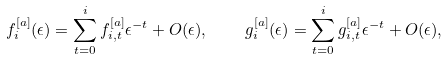<formula> <loc_0><loc_0><loc_500><loc_500>f ^ { [ a ] } _ { i } ( \epsilon ) = \sum _ { t = 0 } ^ { i } f ^ { [ a ] } _ { i , t } \epsilon ^ { - t } + O ( \epsilon ) , \quad g ^ { [ a ] } _ { i } ( \epsilon ) = \sum _ { t = 0 } ^ { i } g ^ { [ a ] } _ { i , t } \epsilon ^ { - t } + O ( \epsilon ) ,</formula> 